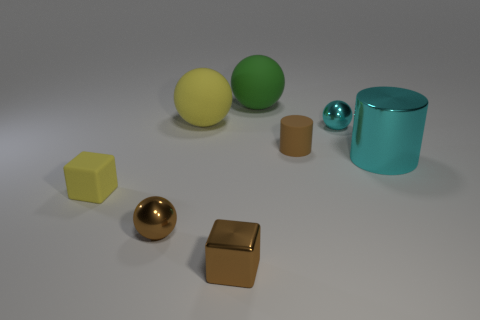What shapes are present in the image, and what does their arrangement suggest? The image contains a variety of shapes including cubes, spheres, and a cylinder. The arrangement is somewhat scattered, with no particular pattern, suggesting a random placement or a possible study of geometric forms and materials. 